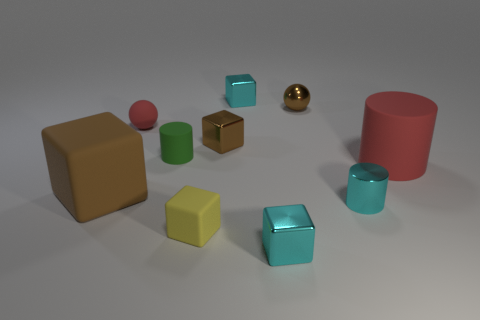Subtract all cyan blocks. How many blocks are left? 3 Subtract all spheres. How many objects are left? 8 Subtract all red balls. How many balls are left? 1 Subtract 1 balls. How many balls are left? 1 Add 7 small green things. How many small green things exist? 8 Subtract 0 gray cubes. How many objects are left? 10 Subtract all gray cubes. Subtract all red spheres. How many cubes are left? 5 Subtract all gray balls. How many cyan cubes are left? 2 Subtract all red balls. Subtract all large blue metal things. How many objects are left? 9 Add 6 cyan cylinders. How many cyan cylinders are left? 7 